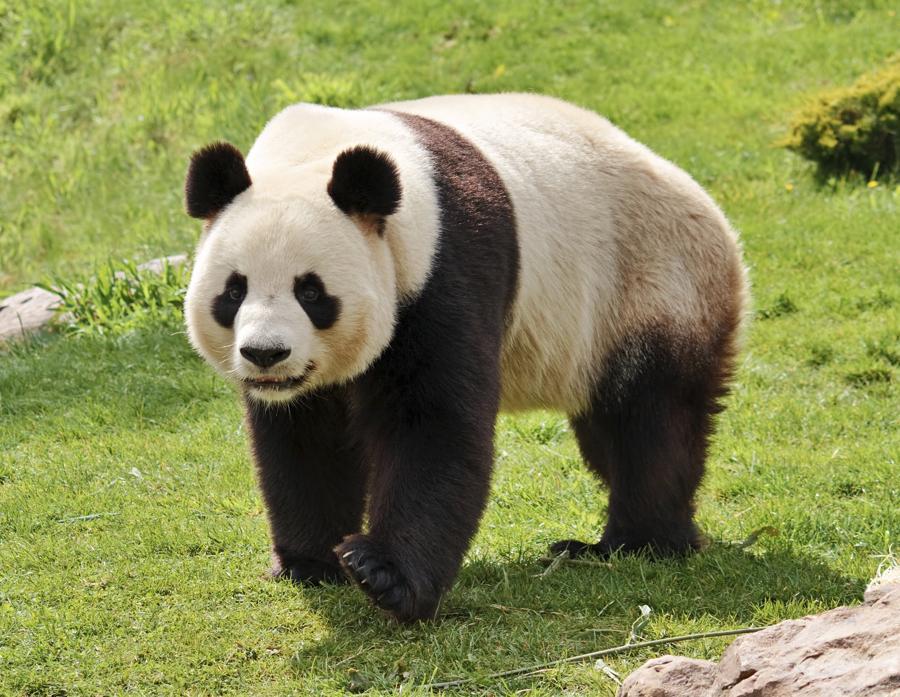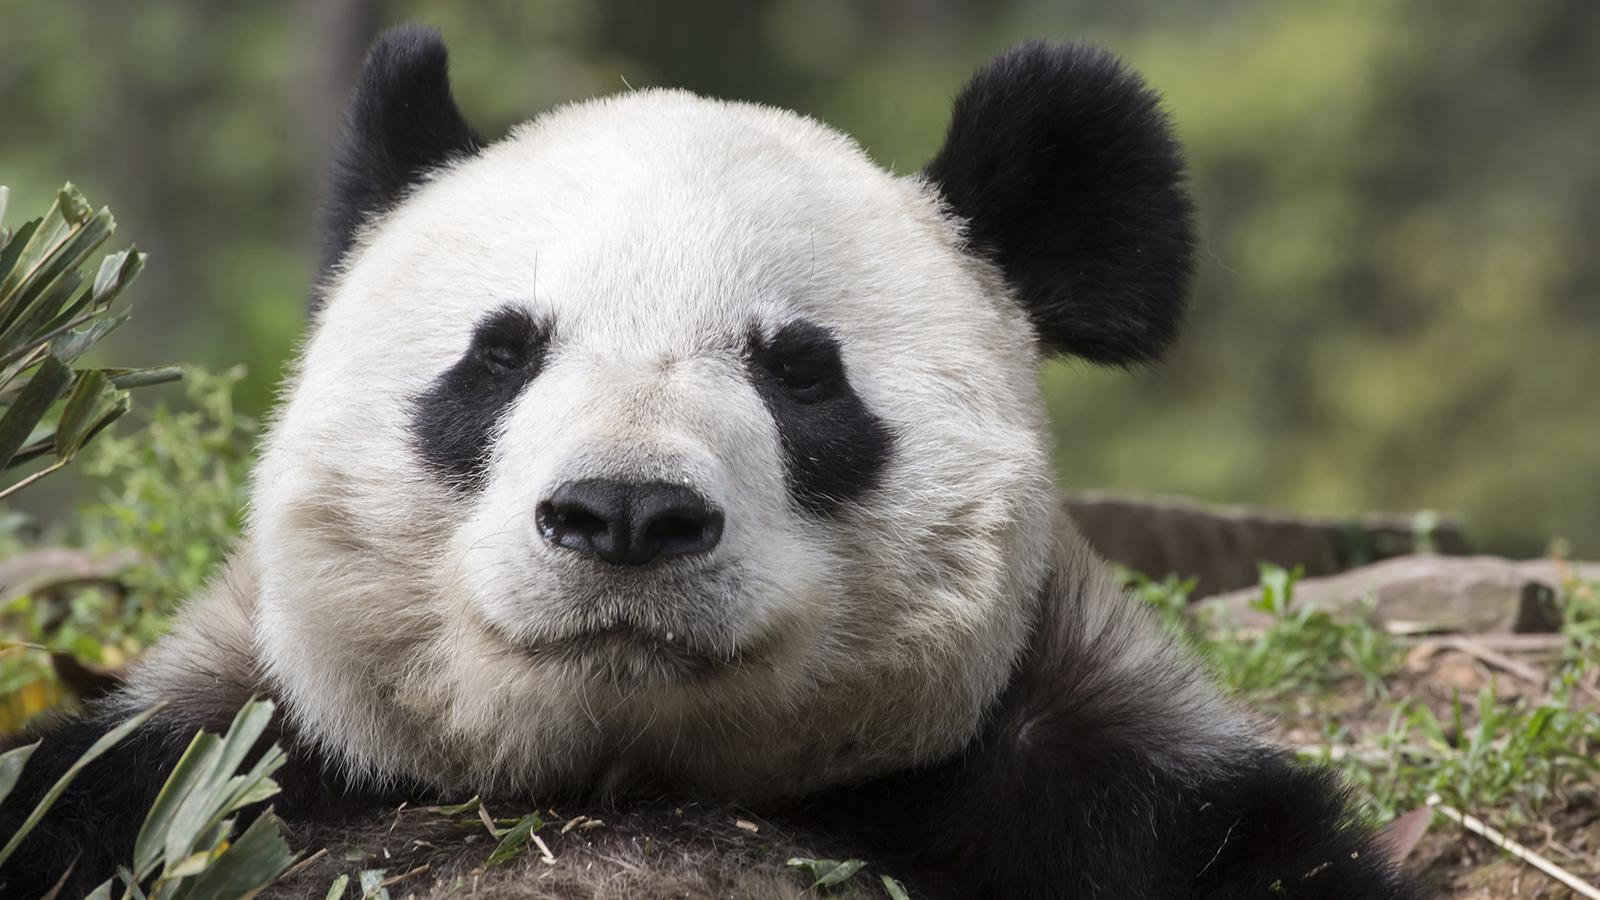The first image is the image on the left, the second image is the image on the right. For the images displayed, is the sentence "a single panda is eating bamboo in the pair of images" factually correct? Answer yes or no. No. The first image is the image on the left, the second image is the image on the right. Assess this claim about the two images: "There is a lone panda bear sitting down while eating some bamboo.". Correct or not? Answer yes or no. No. The first image is the image on the left, the second image is the image on the right. Given the left and right images, does the statement "There is a Panda sitting and eating bamboo." hold true? Answer yes or no. No. The first image is the image on the left, the second image is the image on the right. Examine the images to the left and right. Is the description "In both image the panda is eating." accurate? Answer yes or no. No. 